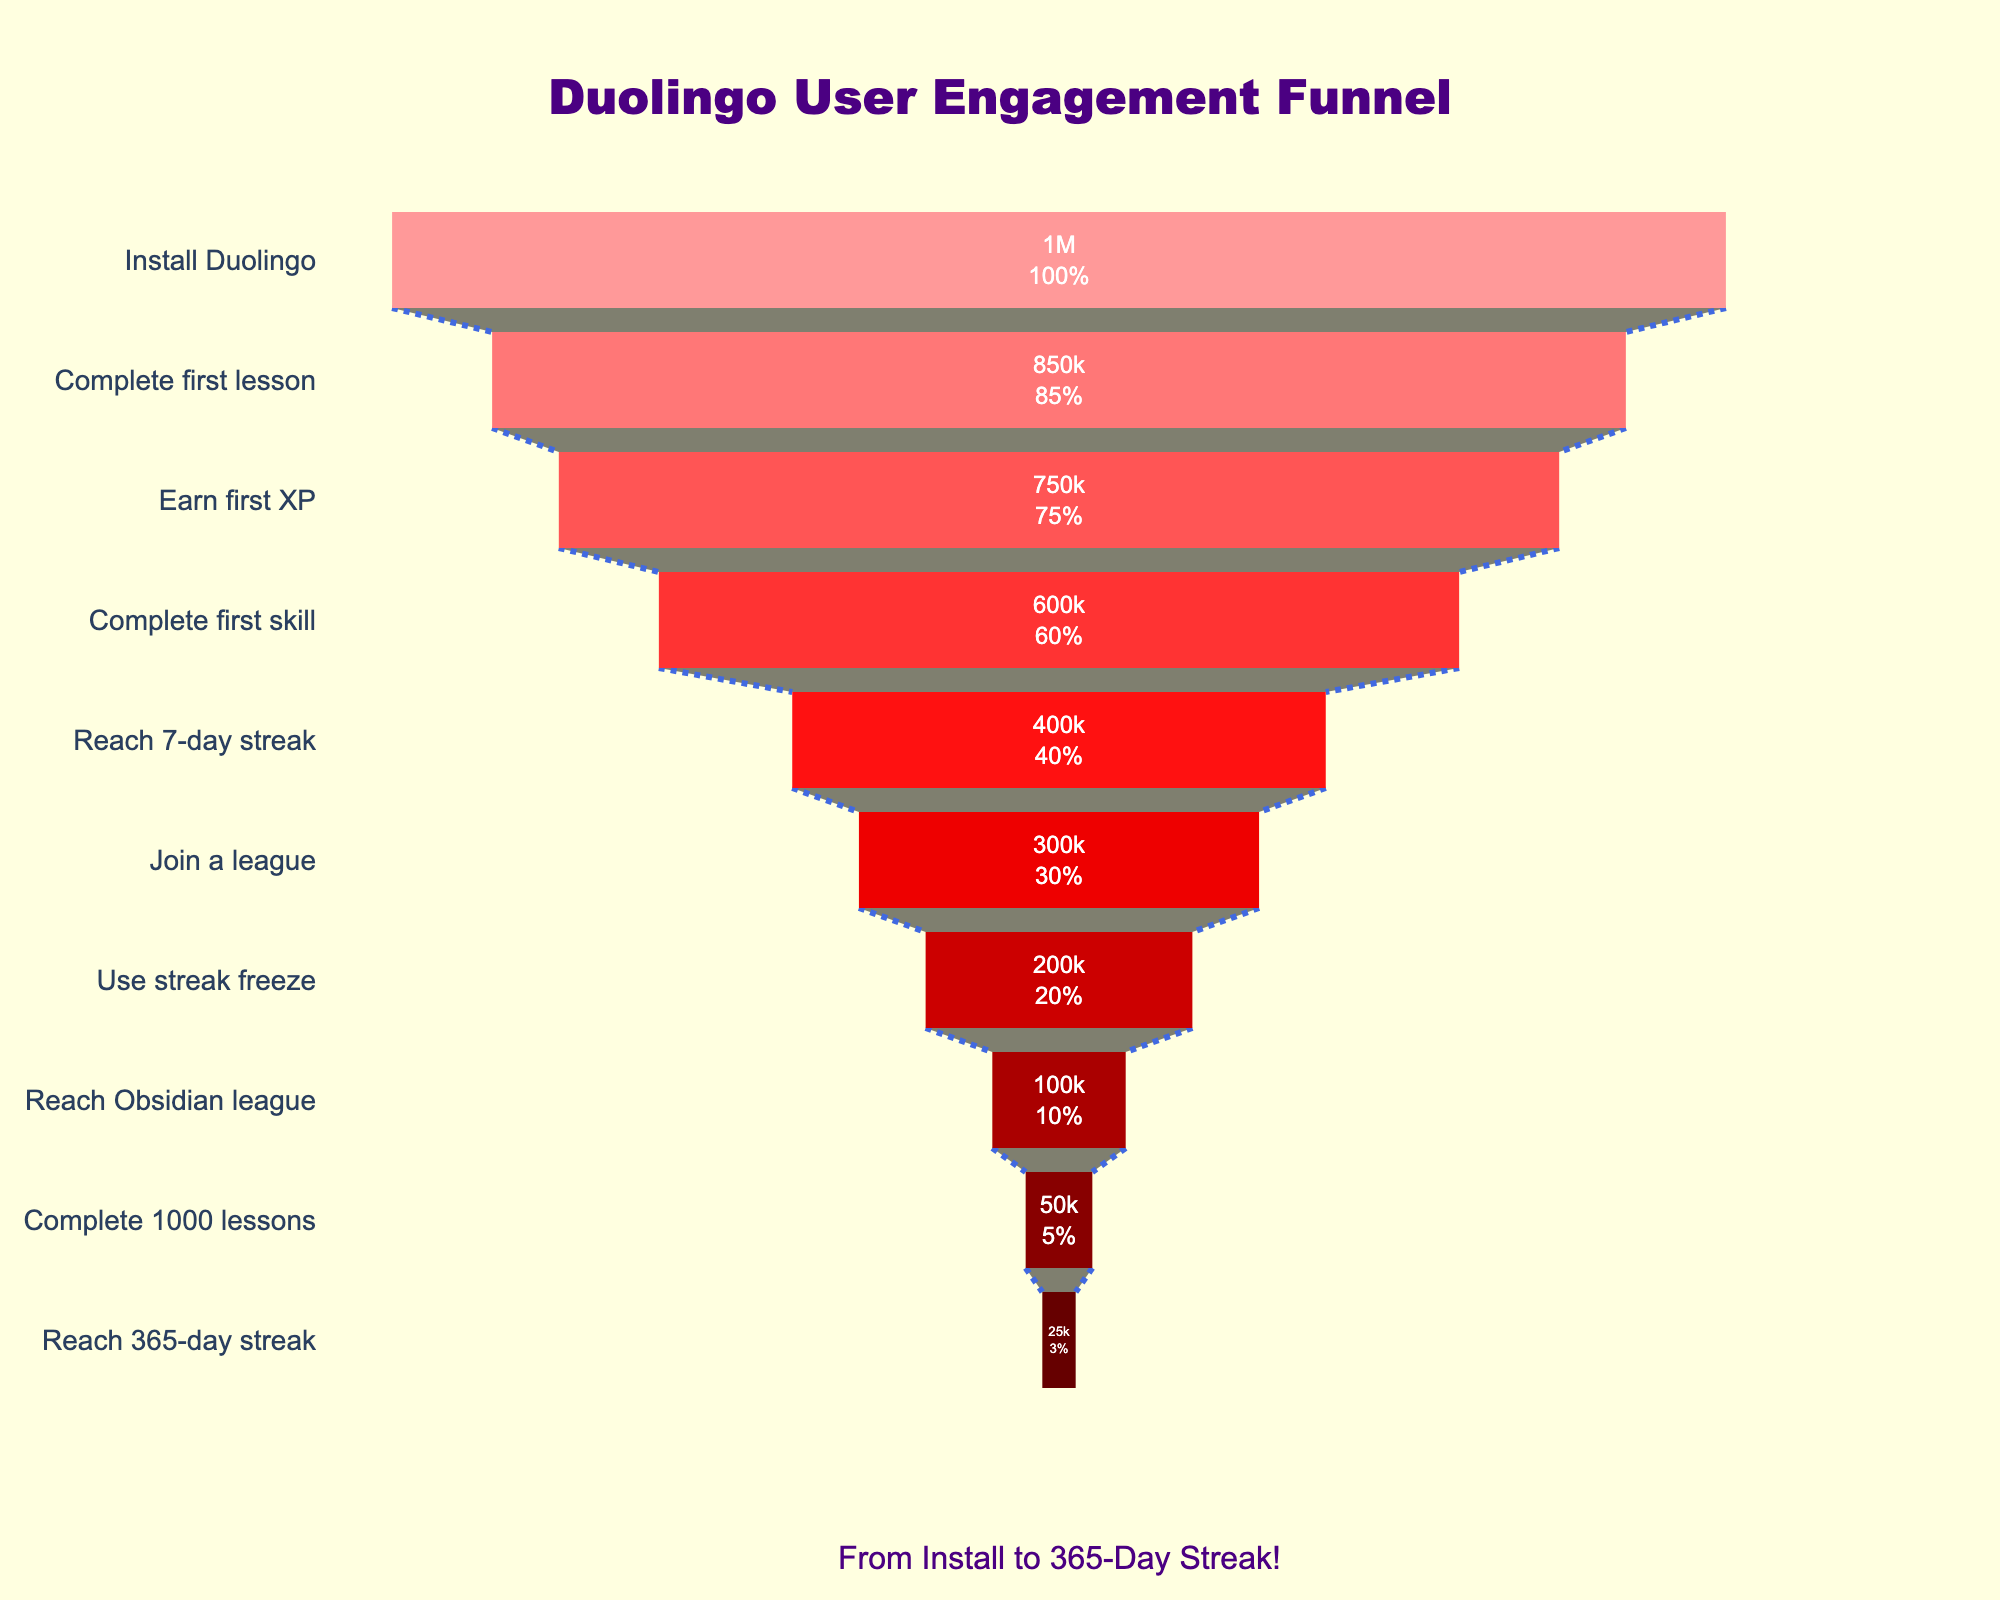What is the title of the funnel chart? The visual title is located at the top center of the chart. It reads "Duolingo User Engagement Funnel".
Answer: Duolingo User Engagement Funnel How many users completed their first lesson? Look at the bar labeled "Complete first lesson". It shows the number of users as 850,000.
Answer: 850,000 What is the total number of stages shown in the funnel? Count the number of labeled stages on the y-axis. There are 10 stages listed.
Answer: 10 What percentage of users installed Duolingo but did not reach the first skill? Calculate the percentage of users who did not reach the first skill. Starting from 1,000,000 users who installed Duolingo and 600,000 who completed the first skill, subtract to find the difference (1,000,000 - 600,000 = 400,000). Then, divide by the initial number of users and multiply by 100 to find the percentage: (400,000 / 1,000,000) * 100 = 40%.
Answer: 40% Which stage has the largest drop in users compared to the previous stage? Compare the difference in the number of users between each consecutive stage. The largest drop is between "Complete first skill" (600,000) and "Reach 7-day streak" (400,000), a drop of 200,000 users.
Answer: Complete first skill to Reach 7-day streak What is the color of the bar for users who reached a 365-day streak? The bar for the "Reach 365-day streak" stage has a dark red color, specifically in the darkest hue presented in the funnel.
Answer: Dark red From which stage do half of the initial users drop off? Half of the initial users is 500,000 (half of 1,000,000). The first stage below this threshold is "Complete first skill" with 600,000 users, and the next stage "Reach 7-day streak" has 400,000 users, which is below half.
Answer: Reach 7-day streak What is the ratio of users who join a league to those who complete 1000 lessons? The number of users who join a league is 300,000 and those who complete 1000 lessons is 50,000. Divide the former by the latter: 300,000 / 50,000 = 6.
Answer: 6 Which stage has the smallest number of users? Look for the smallest bar in the chart, corresponding to the "Reach 365-day streak" stage, which has 25,000 users.
Answer: Reach 365-day streak What’s the percentage of users who earn their first XP out of those who installed Duolingo? Start with the number of users who installed Duolingo (1,000,000). The number of users who earned their first XP is 750,000. So, (750,000 / 1,000,000) * 100 = 75%.
Answer: 75% 